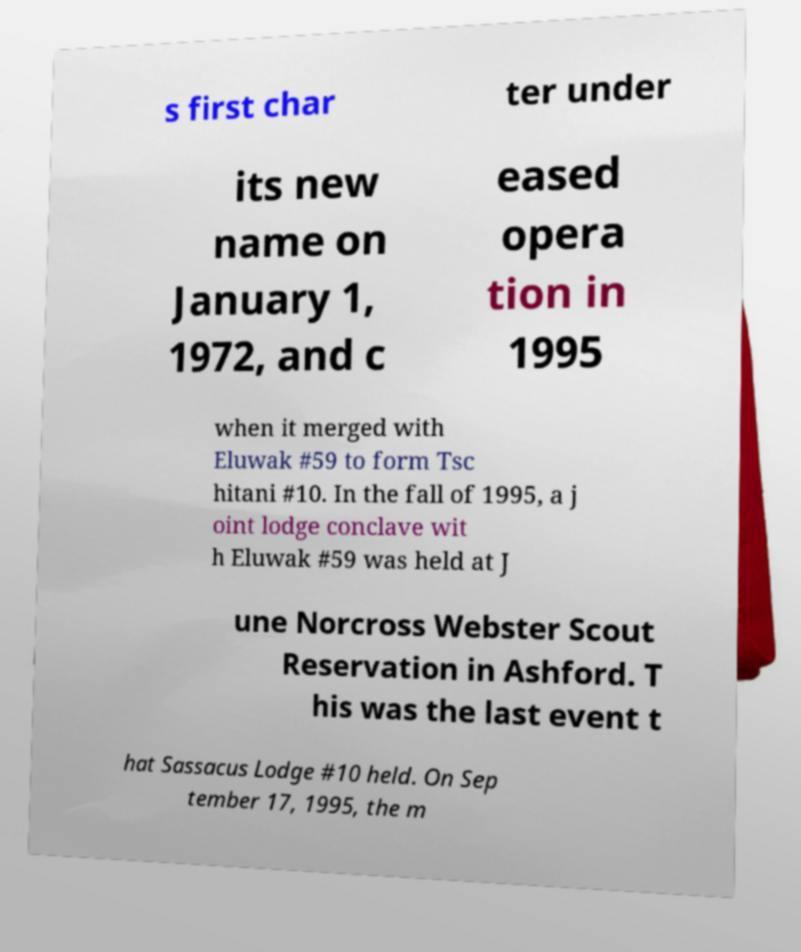There's text embedded in this image that I need extracted. Can you transcribe it verbatim? s first char ter under its new name on January 1, 1972, and c eased opera tion in 1995 when it merged with Eluwak #59 to form Tsc hitani #10. In the fall of 1995, a j oint lodge conclave wit h Eluwak #59 was held at J une Norcross Webster Scout Reservation in Ashford. T his was the last event t hat Sassacus Lodge #10 held. On Sep tember 17, 1995, the m 